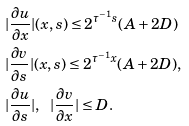<formula> <loc_0><loc_0><loc_500><loc_500>& | \frac { \partial u } { \partial x } | ( x , s ) \leq 2 ^ { \tau ^ { - 1 } s } ( A + 2 D ) \\ & | \frac { \partial v } { \partial s } | ( x , s ) \leq 2 ^ { \tau ^ { - 1 } x } ( A + 2 D ) , \\ & | \frac { \partial u } { \partial s } | , \ \ | \frac { \partial v } { \partial x } | \leq D .</formula> 